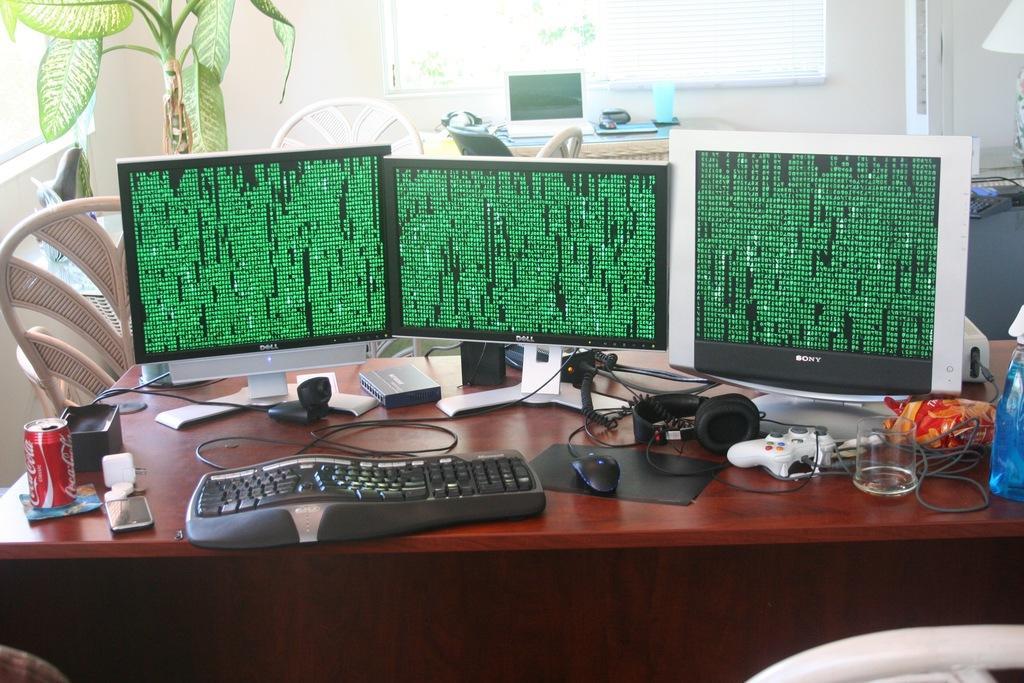Describe this image in one or two sentences. In the center we can see table,on table we can see the monitors,keyboard,and,mouse,glass etc. Coming to the back ground we can see the wall,plant and few empty chairs. 